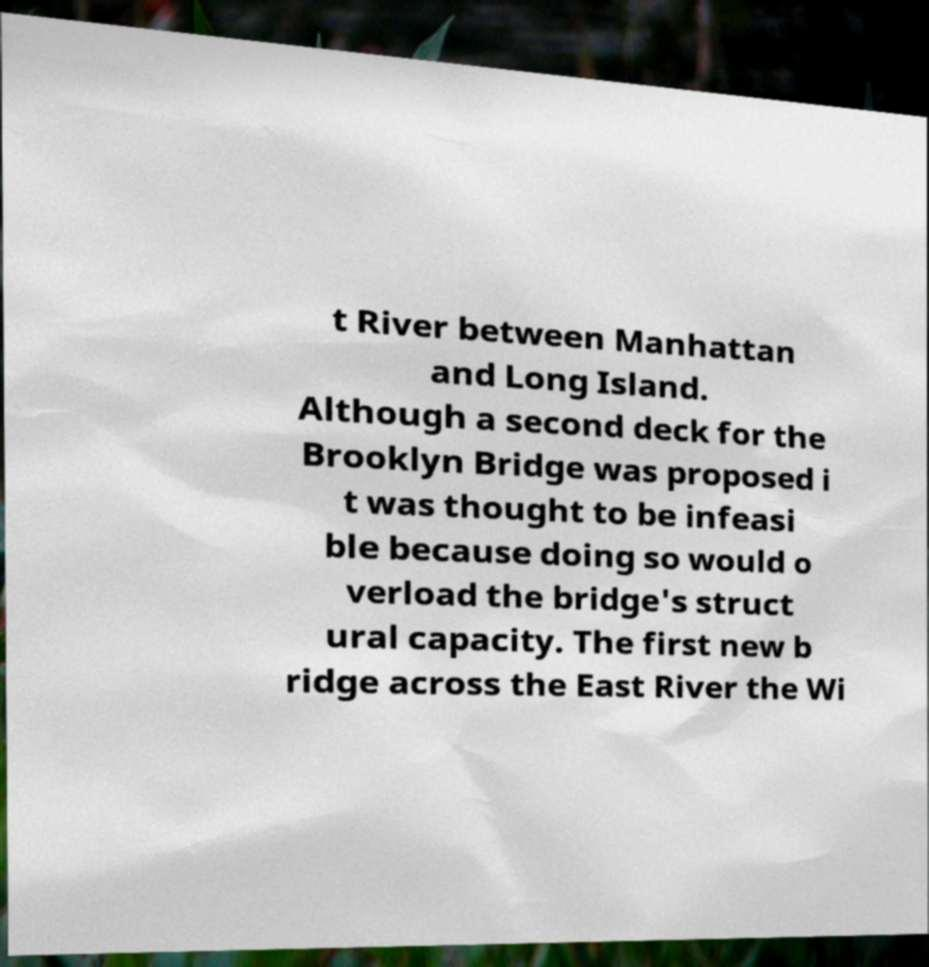Please read and relay the text visible in this image. What does it say? t River between Manhattan and Long Island. Although a second deck for the Brooklyn Bridge was proposed i t was thought to be infeasi ble because doing so would o verload the bridge's struct ural capacity. The first new b ridge across the East River the Wi 